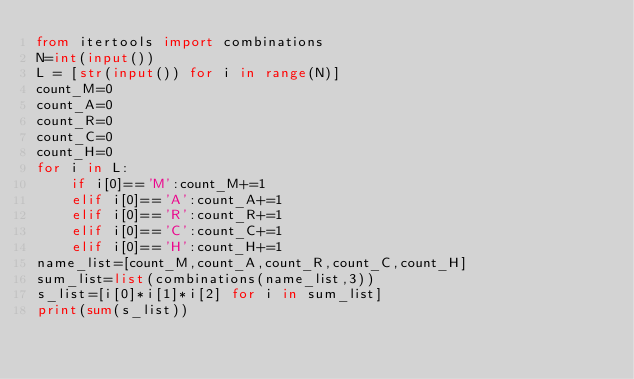Convert code to text. <code><loc_0><loc_0><loc_500><loc_500><_Python_>from itertools import combinations
N=int(input())
L = [str(input()) for i in range(N)]
count_M=0
count_A=0
count_R=0
count_C=0
count_H=0
for i in L:
    if i[0]=='M':count_M+=1
    elif i[0]=='A':count_A+=1
    elif i[0]=='R':count_R+=1
    elif i[0]=='C':count_C+=1
    elif i[0]=='H':count_H+=1
name_list=[count_M,count_A,count_R,count_C,count_H]
sum_list=list(combinations(name_list,3))
s_list=[i[0]*i[1]*i[2] for i in sum_list]
print(sum(s_list))</code> 